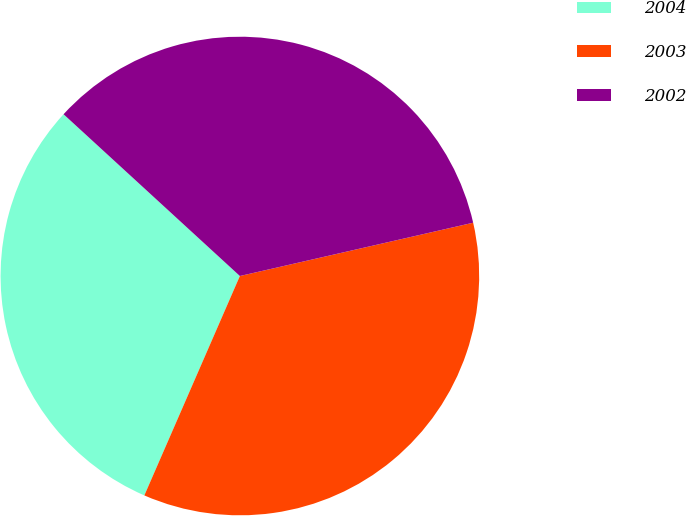<chart> <loc_0><loc_0><loc_500><loc_500><pie_chart><fcel>2004<fcel>2003<fcel>2002<nl><fcel>30.28%<fcel>35.11%<fcel>34.61%<nl></chart> 